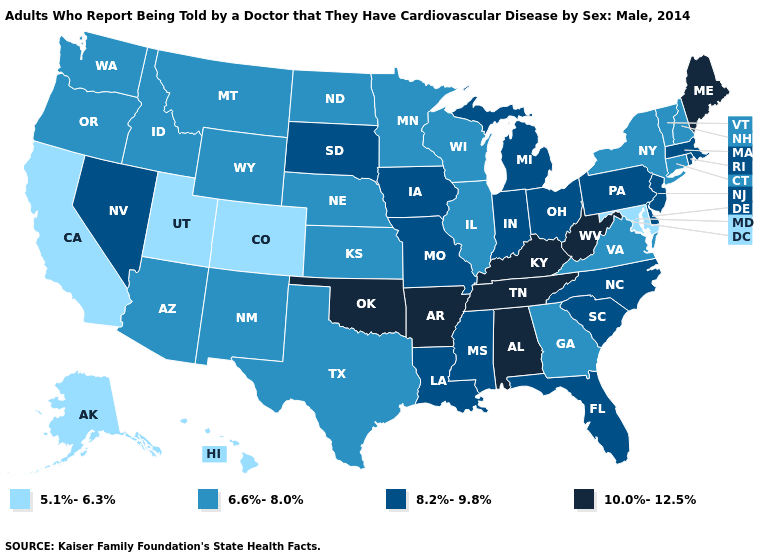Name the states that have a value in the range 10.0%-12.5%?
Quick response, please. Alabama, Arkansas, Kentucky, Maine, Oklahoma, Tennessee, West Virginia. Among the states that border Maine , which have the highest value?
Write a very short answer. New Hampshire. Among the states that border Louisiana , does Texas have the lowest value?
Quick response, please. Yes. Which states hav the highest value in the MidWest?
Keep it brief. Indiana, Iowa, Michigan, Missouri, Ohio, South Dakota. What is the highest value in the USA?
Answer briefly. 10.0%-12.5%. Name the states that have a value in the range 8.2%-9.8%?
Be succinct. Delaware, Florida, Indiana, Iowa, Louisiana, Massachusetts, Michigan, Mississippi, Missouri, Nevada, New Jersey, North Carolina, Ohio, Pennsylvania, Rhode Island, South Carolina, South Dakota. Among the states that border Tennessee , does Alabama have the highest value?
Short answer required. Yes. Does Hawaii have the highest value in the West?
Give a very brief answer. No. Does New Mexico have the same value as Alabama?
Short answer required. No. Is the legend a continuous bar?
Write a very short answer. No. Name the states that have a value in the range 5.1%-6.3%?
Be succinct. Alaska, California, Colorado, Hawaii, Maryland, Utah. Does the map have missing data?
Write a very short answer. No. What is the lowest value in states that border Ohio?
Keep it brief. 8.2%-9.8%. Does Missouri have a lower value than Arkansas?
Short answer required. Yes. Among the states that border Nebraska , does Missouri have the highest value?
Quick response, please. Yes. 